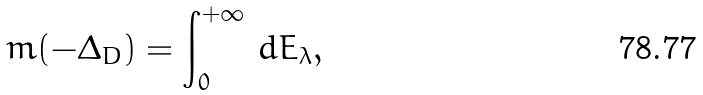Convert formula to latex. <formula><loc_0><loc_0><loc_500><loc_500>m ( - \Delta _ { D } ) = \int _ { 0 } ^ { + \infty } \, d E _ { \lambda } ,</formula> 